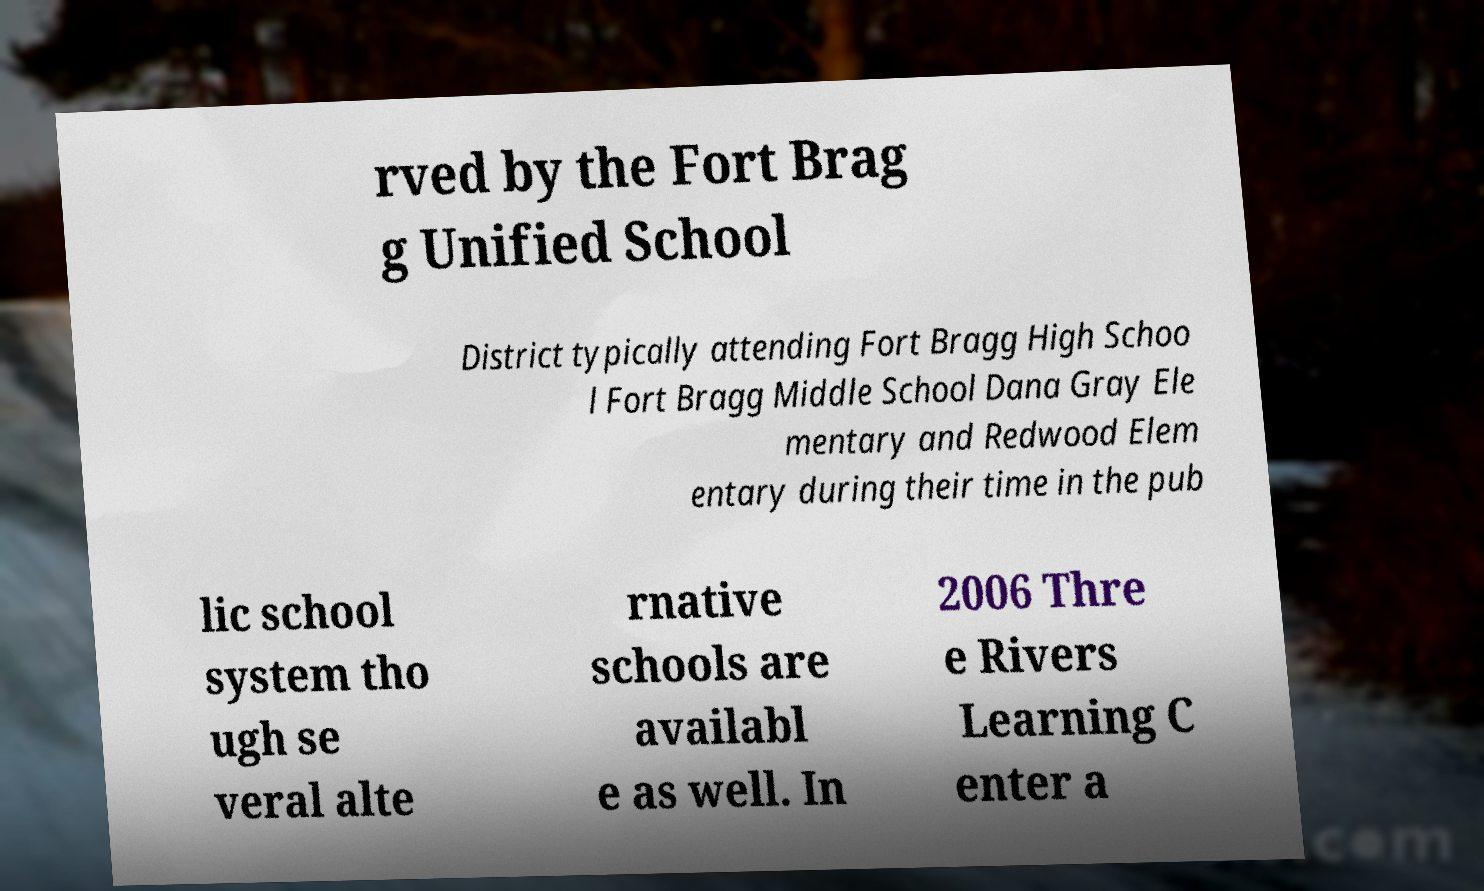What messages or text are displayed in this image? I need them in a readable, typed format. rved by the Fort Brag g Unified School District typically attending Fort Bragg High Schoo l Fort Bragg Middle School Dana Gray Ele mentary and Redwood Elem entary during their time in the pub lic school system tho ugh se veral alte rnative schools are availabl e as well. In 2006 Thre e Rivers Learning C enter a 